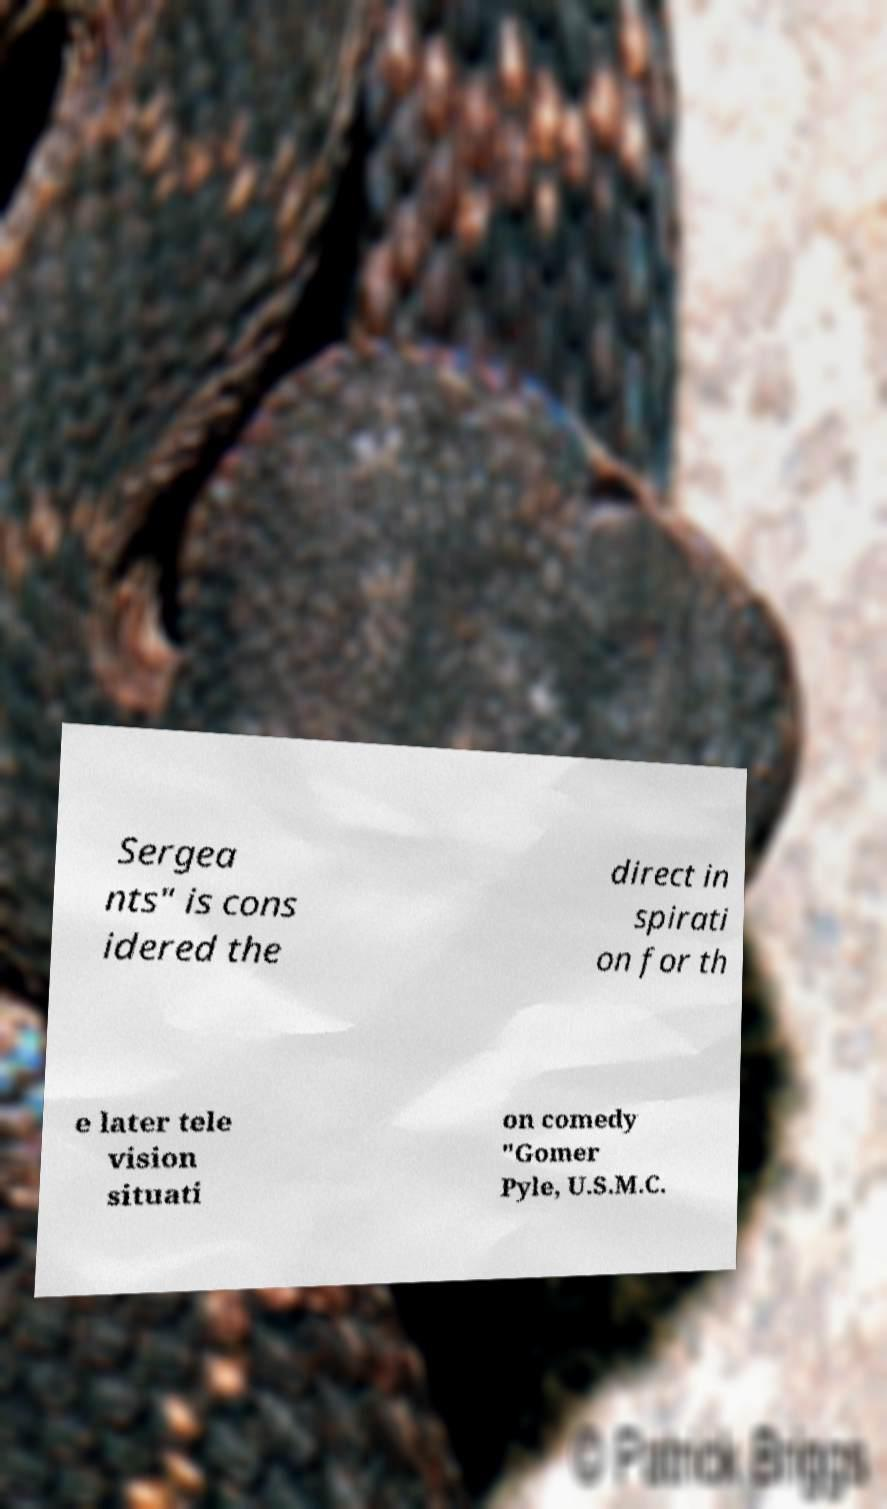What messages or text are displayed in this image? I need them in a readable, typed format. Sergea nts" is cons idered the direct in spirati on for th e later tele vision situati on comedy "Gomer Pyle, U.S.M.C. 